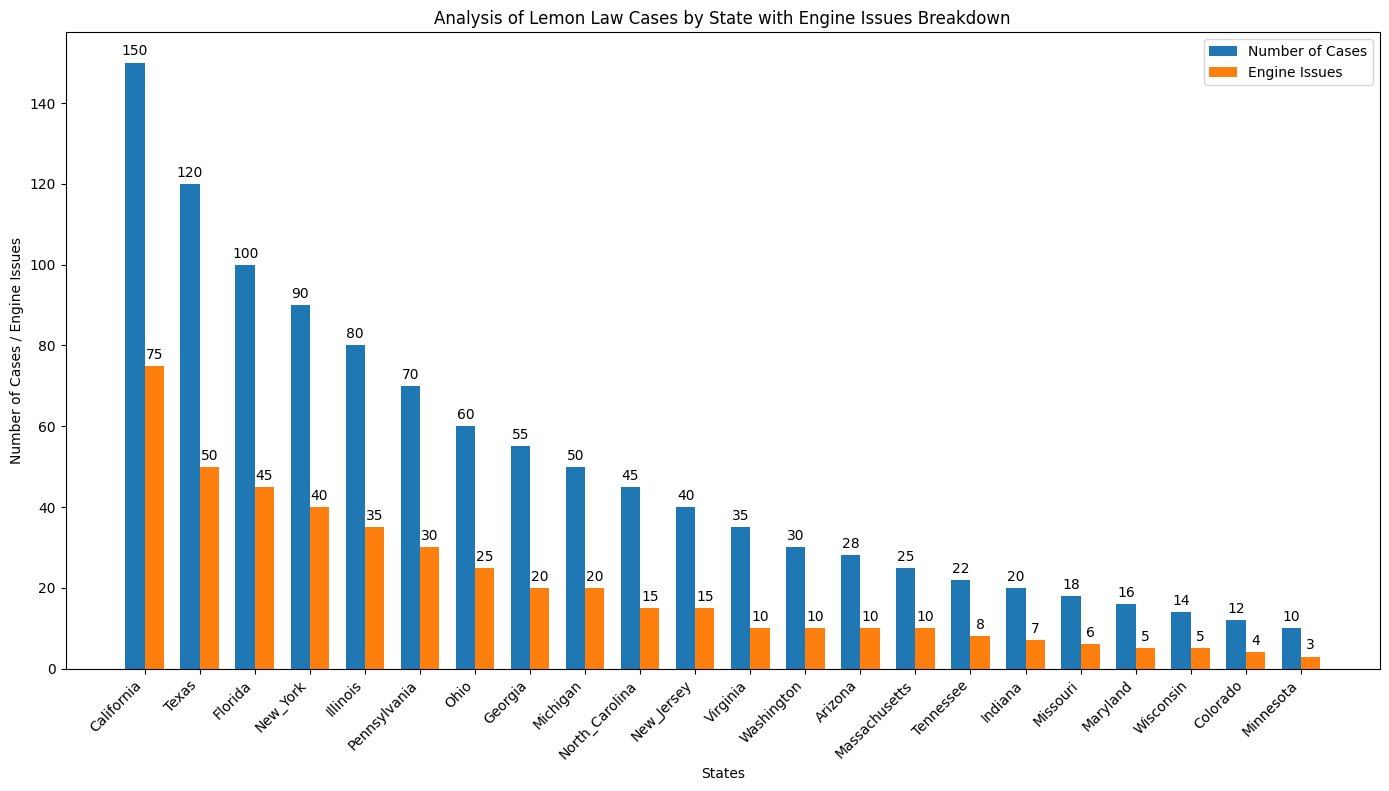Which state has the highest number of lemon law cases? The state with the highest bar in the "Number of Cases" bar graph is California. This bar is also annotated with the number 150, indicating it has the highest count.
Answer: California How many states have more than 50 engine issues? From the "Engine Issues" bar graph, the states with bars exceeding the 50 mark are California and Texas.
Answer: 2 Compare the number of lemon law cases in Ohio to Michigan. Which state has more, and by how much? The bar for Ohio in the "Number of Cases" graph is labeled 60, while Michigan's bar is labeled 50. Subtracting these gives 60 - 50 = 10.
Answer: Ohio, by 10 What is the difference between the number of lemon law cases in New Jersey and Virginia? In the "Number of Cases" bar graph, New Jersey is annotated with 40 cases, and Virginia is annotated with 35 cases. The difference is 40 - 35 = 5.
Answer: 5 How do engine issues compare to total lemon law cases in Florida? In the bar graph, both the "Number of Cases" and "Engine Issues" bars for Florida are labeled. The "Number of Cases" shows 100, while the "Engine Issues" shows 45. Comparing these, 45 is less than 100.
Answer: Engine issues < Total cases Which state has an equal number of lemon law cases and engine issues? The "Number of Cases" and "Engine Issues" bars are equal and labeled the same in Michigan. Both are labeled 50.
Answer: Michigan In which state are the engine issues closest to 50? The "Engine Issues" bar for Texas is labeled 50, showing the count is exactly 50.
Answer: Texas What is the combined number of lemon law cases in Illinois, Pennsylvania, and Ohio? Summing the "Number of Cases" in these states: Illinois (80) + Pennsylvania (70) + Ohio (60) = 210.
Answer: 210 Identify the state with the largest difference between lemon law cases and engine issues. The state with the largest difference is California, where the difference between "Number of Cases" (150) and "Engine Issues" (75) is 150 - 75 = 75.
Answer: California, 75 What's the total number of engine issues in California and New York combined? Summing the "Engine Issues" in these states: California (75) + New York (40) = 115.
Answer: 115 